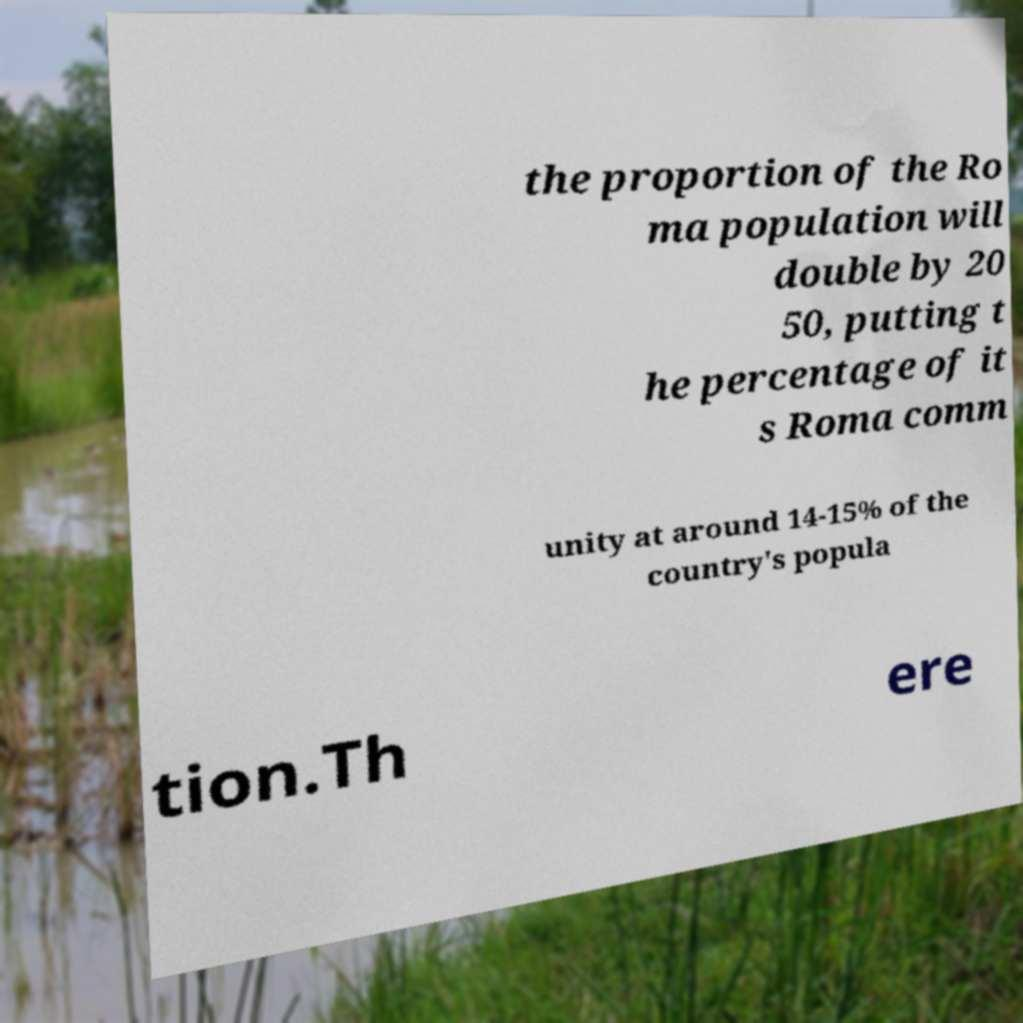I need the written content from this picture converted into text. Can you do that? the proportion of the Ro ma population will double by 20 50, putting t he percentage of it s Roma comm unity at around 14-15% of the country's popula tion.Th ere 